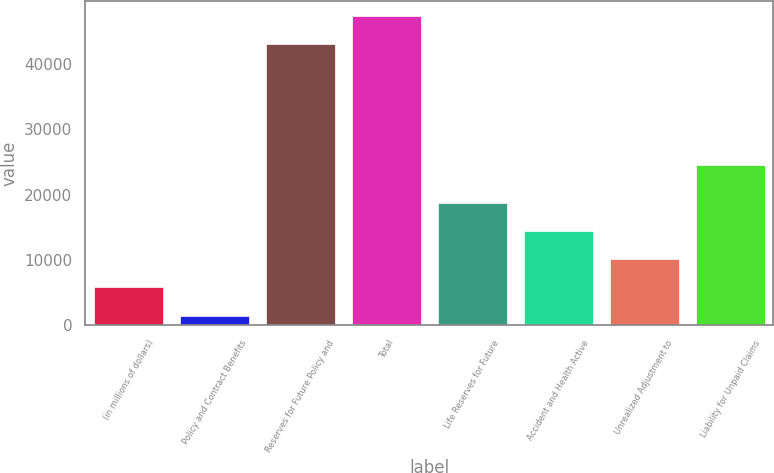Convert chart to OTSL. <chart><loc_0><loc_0><loc_500><loc_500><bar_chart><fcel>(in millions of dollars)<fcel>Policy and Contract Benefits<fcel>Reserves for Future Policy and<fcel>Total<fcel>Life Reserves for Future<fcel>Accident and Health Active<fcel>Unrealized Adjustment to<fcel>Liability for Unpaid Claims<nl><fcel>5799.19<fcel>1494<fcel>43051.9<fcel>47357.1<fcel>18714.8<fcel>14409.6<fcel>10104.4<fcel>24586.5<nl></chart> 